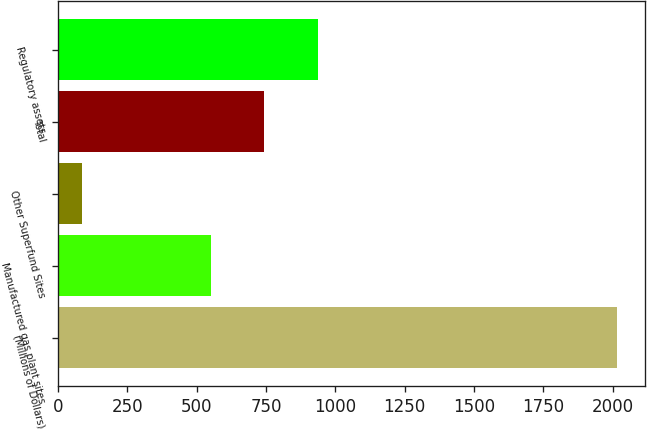Convert chart to OTSL. <chart><loc_0><loc_0><loc_500><loc_500><bar_chart><fcel>(Millions of Dollars)<fcel>Manufactured gas plant sites<fcel>Other Superfund Sites<fcel>Total<fcel>Regulatory assets<nl><fcel>2017<fcel>551<fcel>86<fcel>744.1<fcel>937.2<nl></chart> 